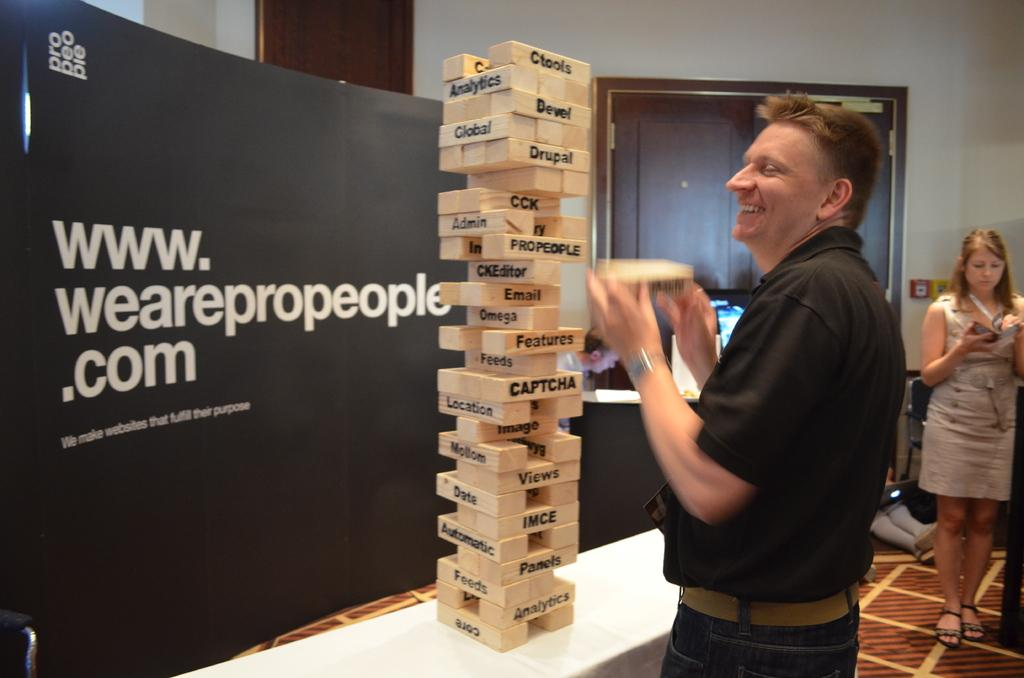<image>
Summarize the visual content of the image. A man stands next to a table playing a tall Jenga game on which each block has a word such as Features and Captcha for example. 